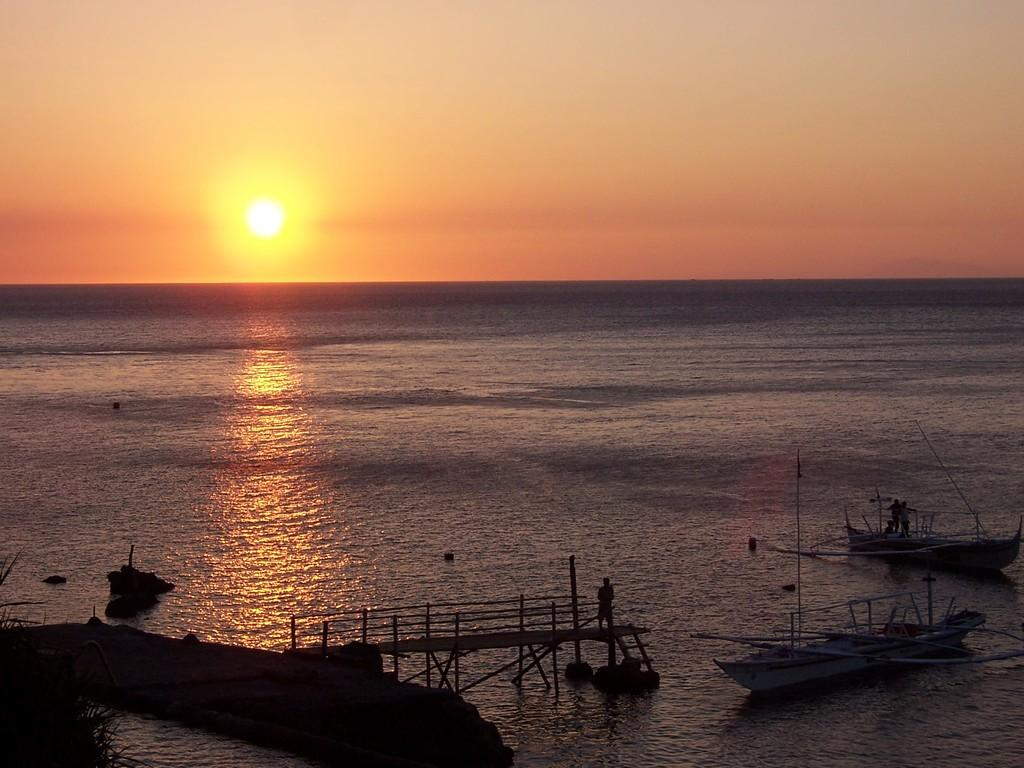What type of natural body of water is present in the image? There is an ocean in the image. What celestial body can be seen in the image? The sun is visible in the image. What else is visible in the image besides the ocean and sun? There is sky visible in the image. How many boats are in the image? There are two boats in the image. Are there any people on the boats? Yes, there are people standing on the boats. What type of church can be seen in the image? There is no church present in the image; it features an ocean, sun, sky, and boats. What is the opinion of the people on the boats about space travel? There is no information about the people's opinions on space travel in the image. 